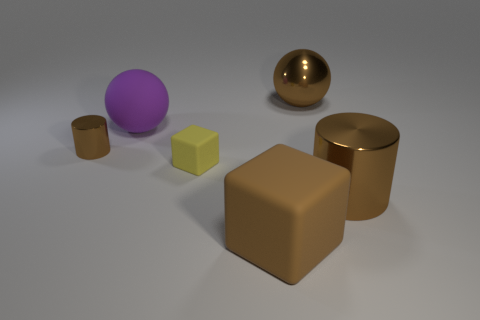What number of objects are either tiny yellow things or balls that are on the left side of the big brown rubber block? There is a single tiny yellow cube in the image but no small yellow spheres. To the left of the prominent brown block, which appears to be rubber, we can find one ball of a gold-bronze color. Therefore, combining the tiny yellow object and the solitary ball on the left, I can confidently say there is a total of two objects matching the criteria. 